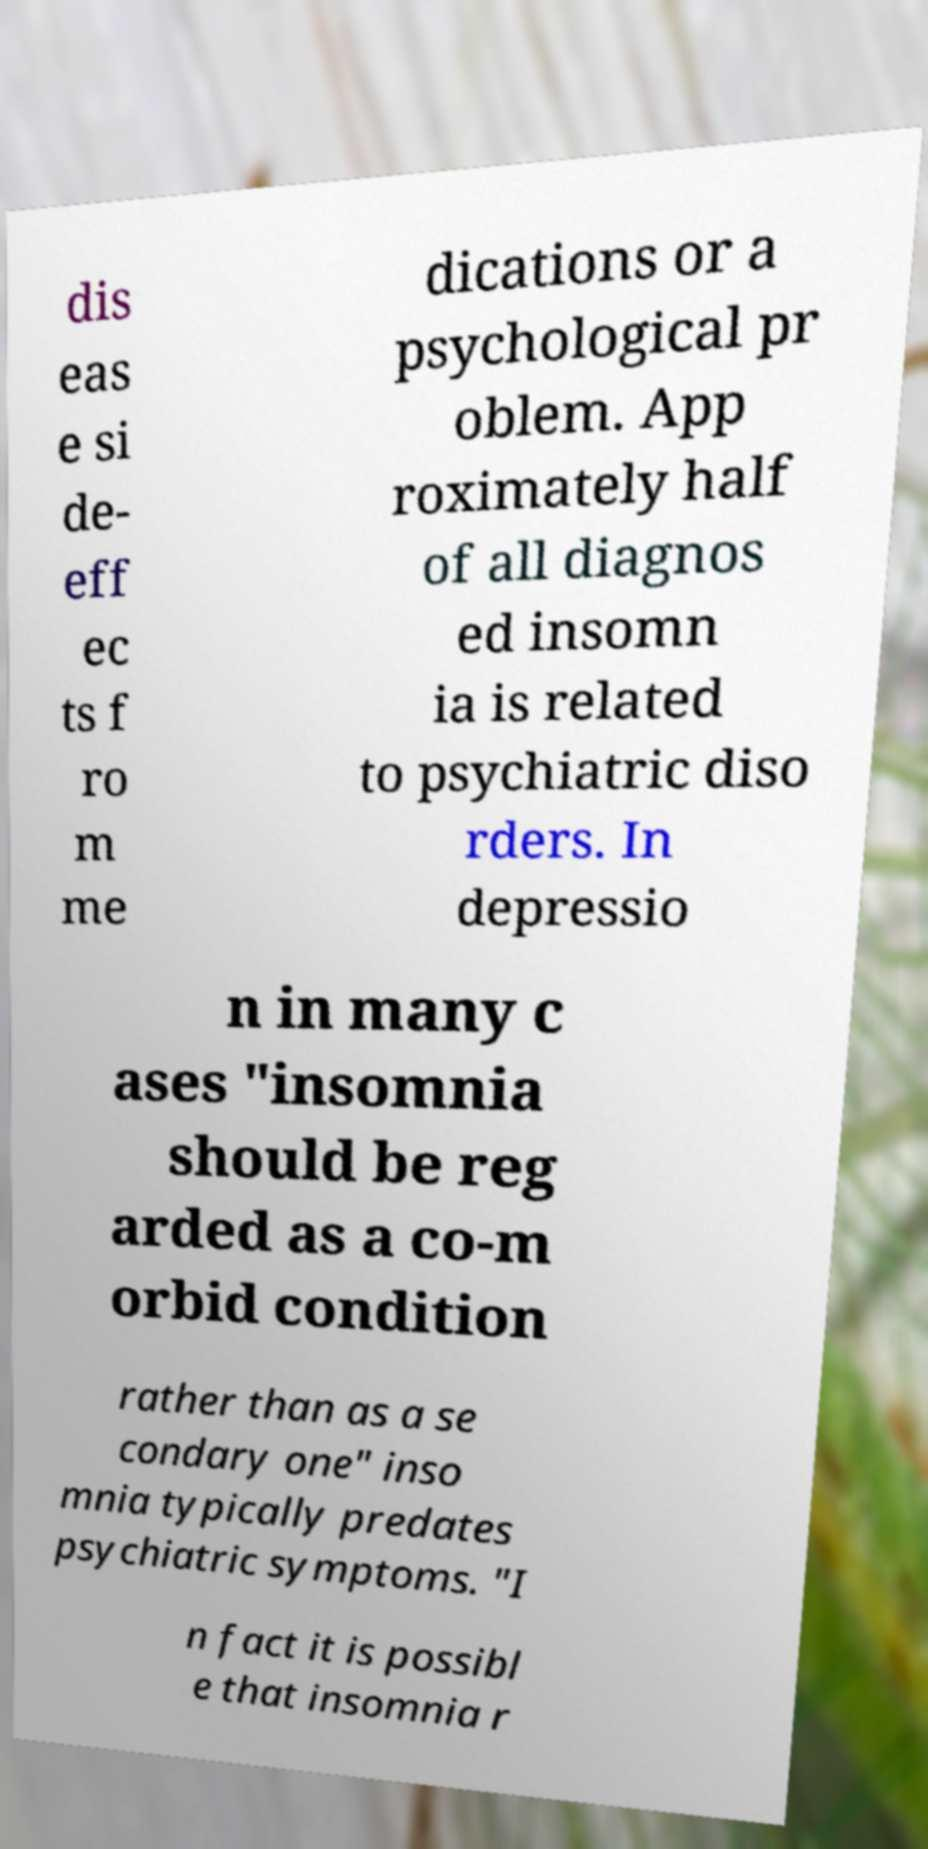There's text embedded in this image that I need extracted. Can you transcribe it verbatim? dis eas e si de- eff ec ts f ro m me dications or a psychological pr oblem. App roximately half of all diagnos ed insomn ia is related to psychiatric diso rders. In depressio n in many c ases "insomnia should be reg arded as a co-m orbid condition rather than as a se condary one" inso mnia typically predates psychiatric symptoms. "I n fact it is possibl e that insomnia r 